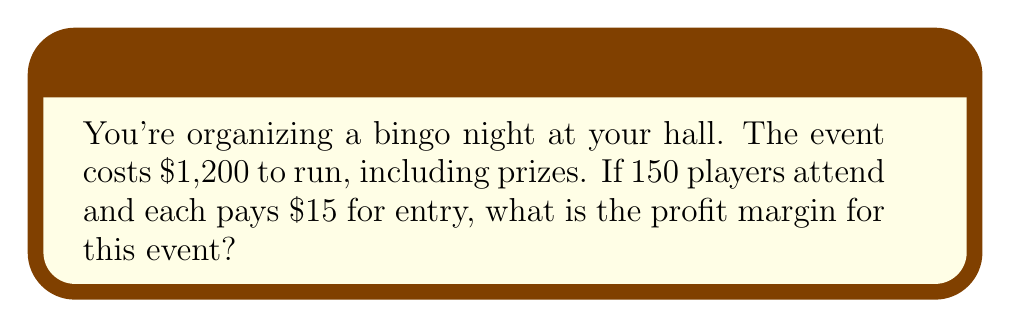What is the answer to this math problem? To calculate the profit margin, we need to follow these steps:

1. Calculate the total revenue:
   Revenue = Number of players × Entry fee
   $$ \text{Revenue} = 150 \times \$15 = \$2,250 $$

2. Calculate the profit:
   Profit = Revenue - Costs
   $$ \text{Profit} = \$2,250 - \$1,200 = \$1,050 $$

3. Calculate the profit margin:
   Profit Margin = (Profit ÷ Revenue) × 100%
   $$ \text{Profit Margin} = \frac{\$1,050}{\$2,250} \times 100\% = 0.4666... \times 100\% = 46.67\% $$

Therefore, the profit margin for this bingo night event is approximately 46.67%.
Answer: 46.67% 